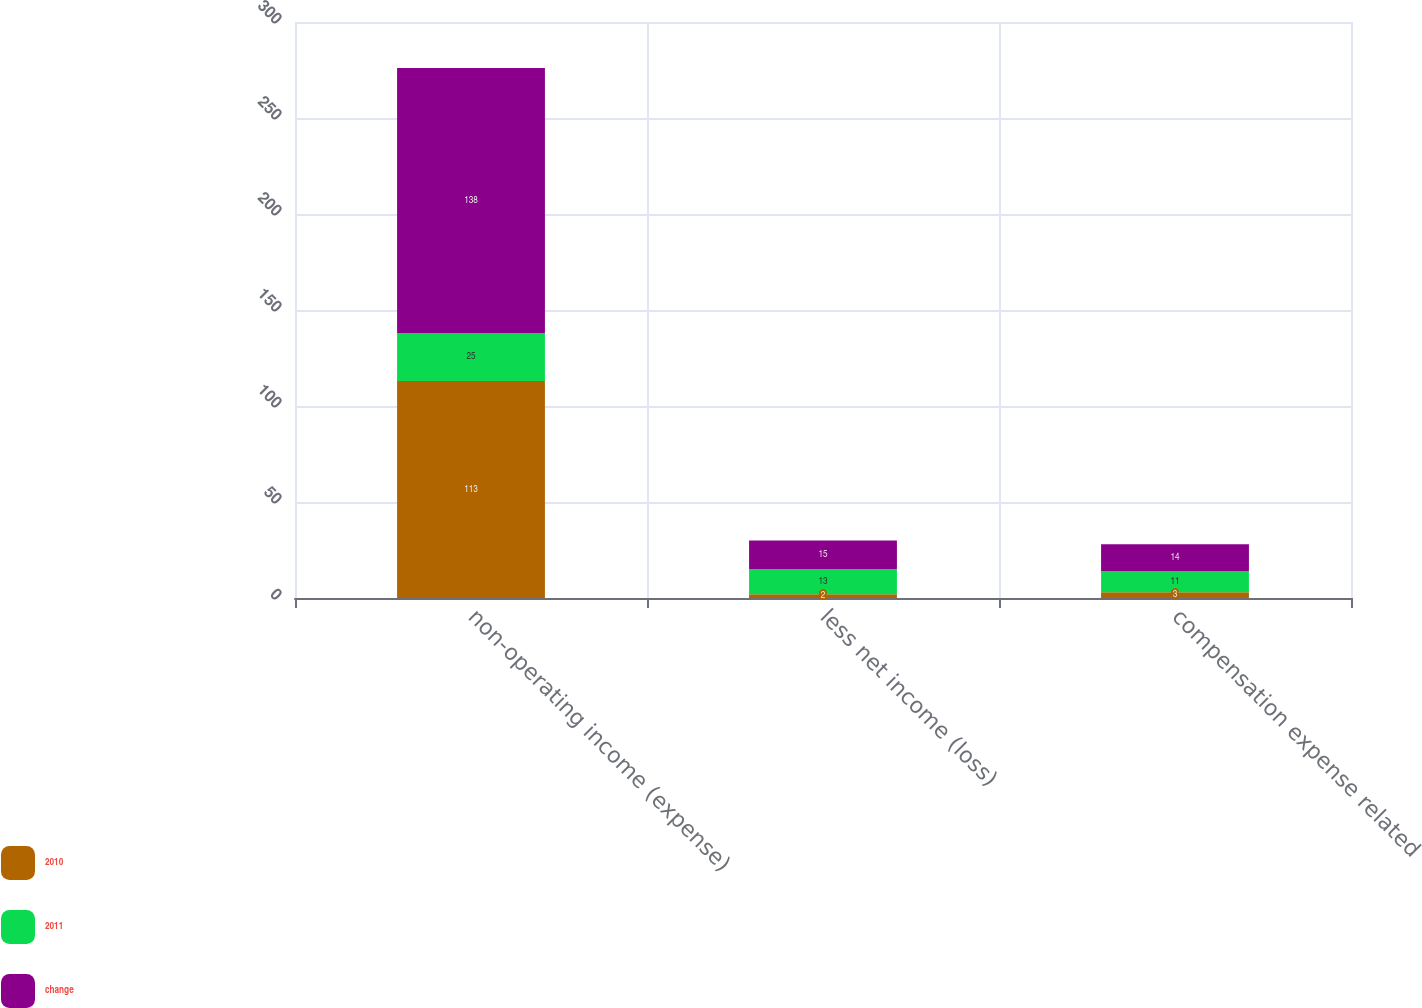<chart> <loc_0><loc_0><loc_500><loc_500><stacked_bar_chart><ecel><fcel>non-operating income (expense)<fcel>less net income (loss)<fcel>compensation expense related<nl><fcel>2010<fcel>113<fcel>2<fcel>3<nl><fcel>2011<fcel>25<fcel>13<fcel>11<nl><fcel>change<fcel>138<fcel>15<fcel>14<nl></chart> 